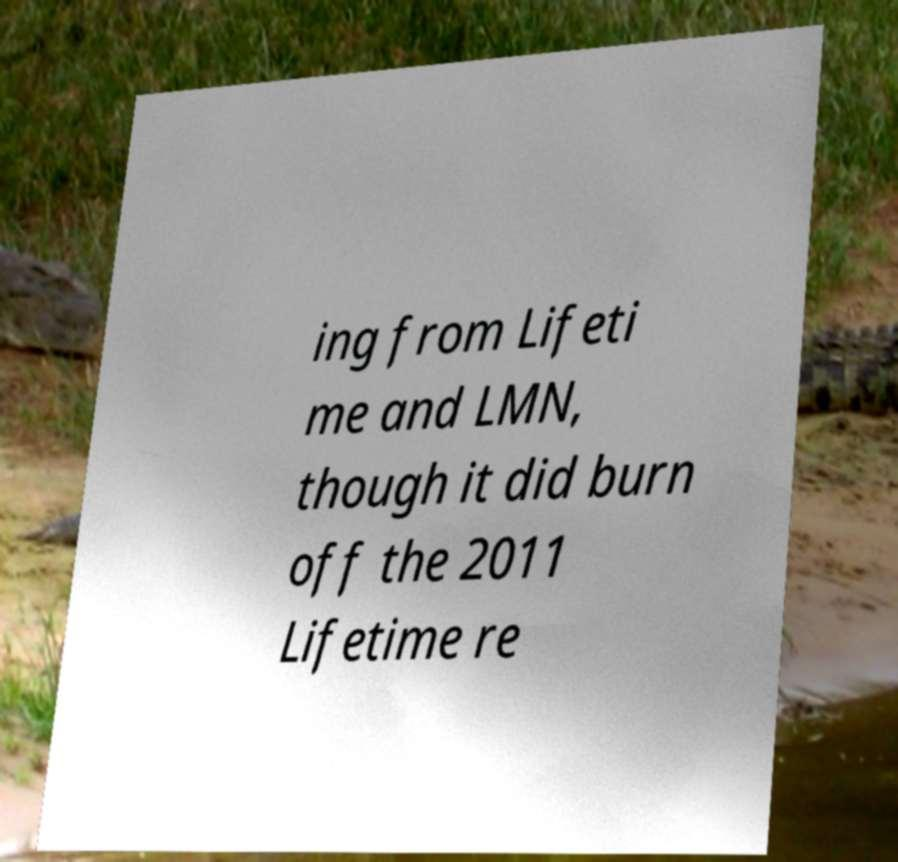I need the written content from this picture converted into text. Can you do that? ing from Lifeti me and LMN, though it did burn off the 2011 Lifetime re 